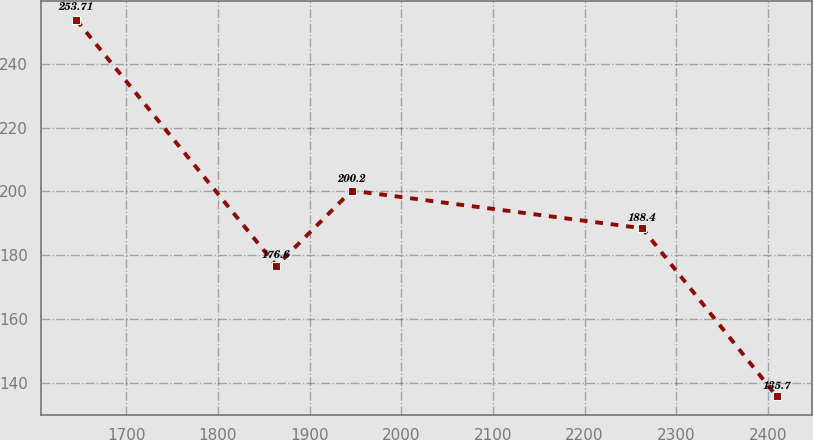<chart> <loc_0><loc_0><loc_500><loc_500><line_chart><ecel><fcel>Unnamed: 1<nl><fcel>1645.57<fcel>253.71<nl><fcel>1863.87<fcel>176.6<nl><fcel>1945.87<fcel>200.2<nl><fcel>2262.9<fcel>188.4<nl><fcel>2409.58<fcel>135.7<nl></chart> 